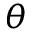<formula> <loc_0><loc_0><loc_500><loc_500>\theta</formula> 